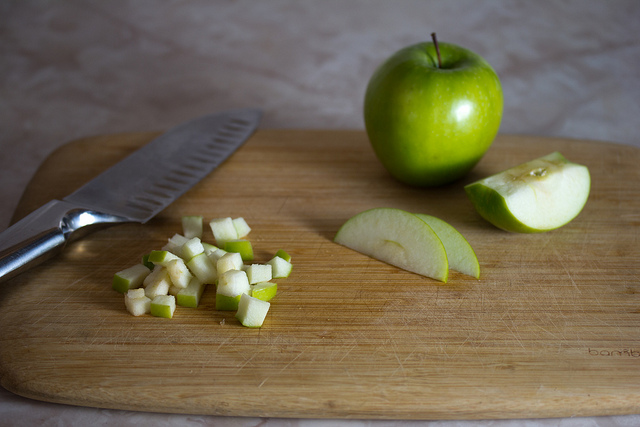Considering the setup in the image, what type of meal or preparation could be underway involving these apples? Given the neatly organized apple pieces and the tools on hand, one might assume a dessert like an apple pie or tart is being prepared. The presence of both whole and diced apples might also suggest a dual-purpose use, perhaps for both a baked dish and a fresh salad to accompany the meal. 